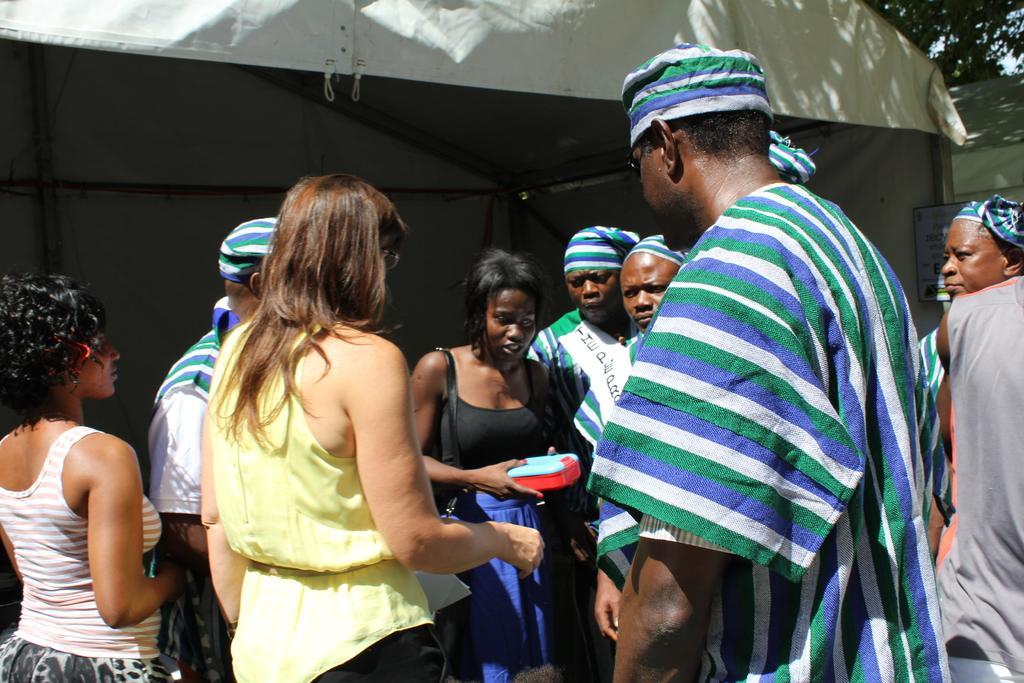In one or two sentences, can you explain what this image depicts? In this picture we can see caps, bag, box, tent, poster, rods and some objects and a group of people standing and in the background we can see trees. 